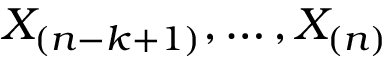Convert formula to latex. <formula><loc_0><loc_0><loc_500><loc_500>X _ { ( n - k + 1 ) } , \dots , X _ { ( n ) }</formula> 